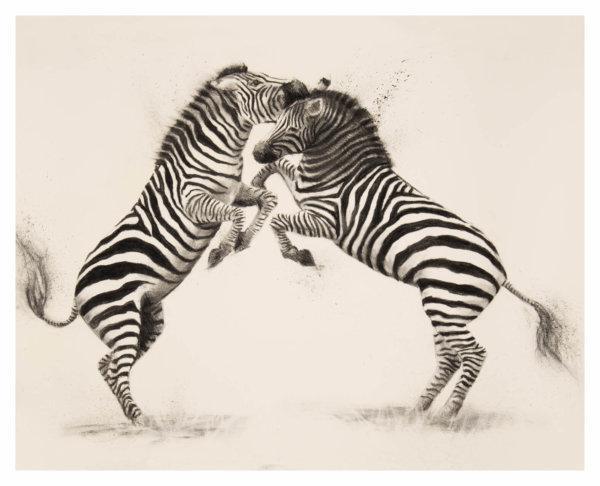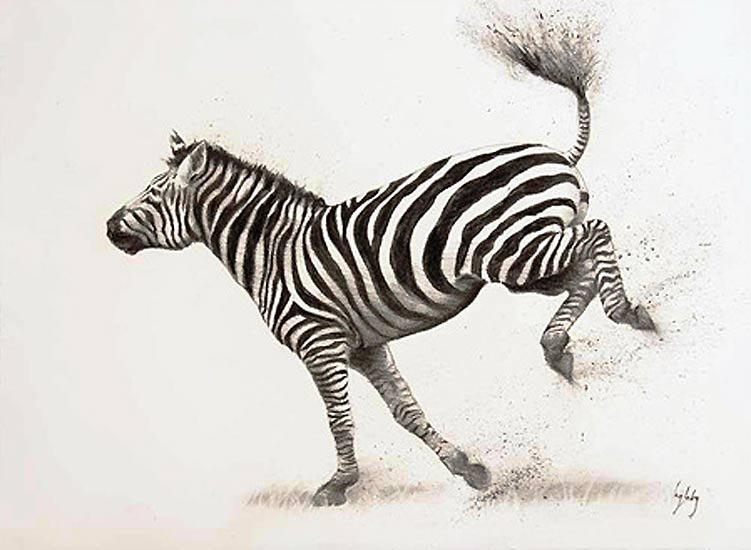The first image is the image on the left, the second image is the image on the right. For the images displayed, is the sentence "There is only one zebra in the right image." factually correct? Answer yes or no. Yes. 